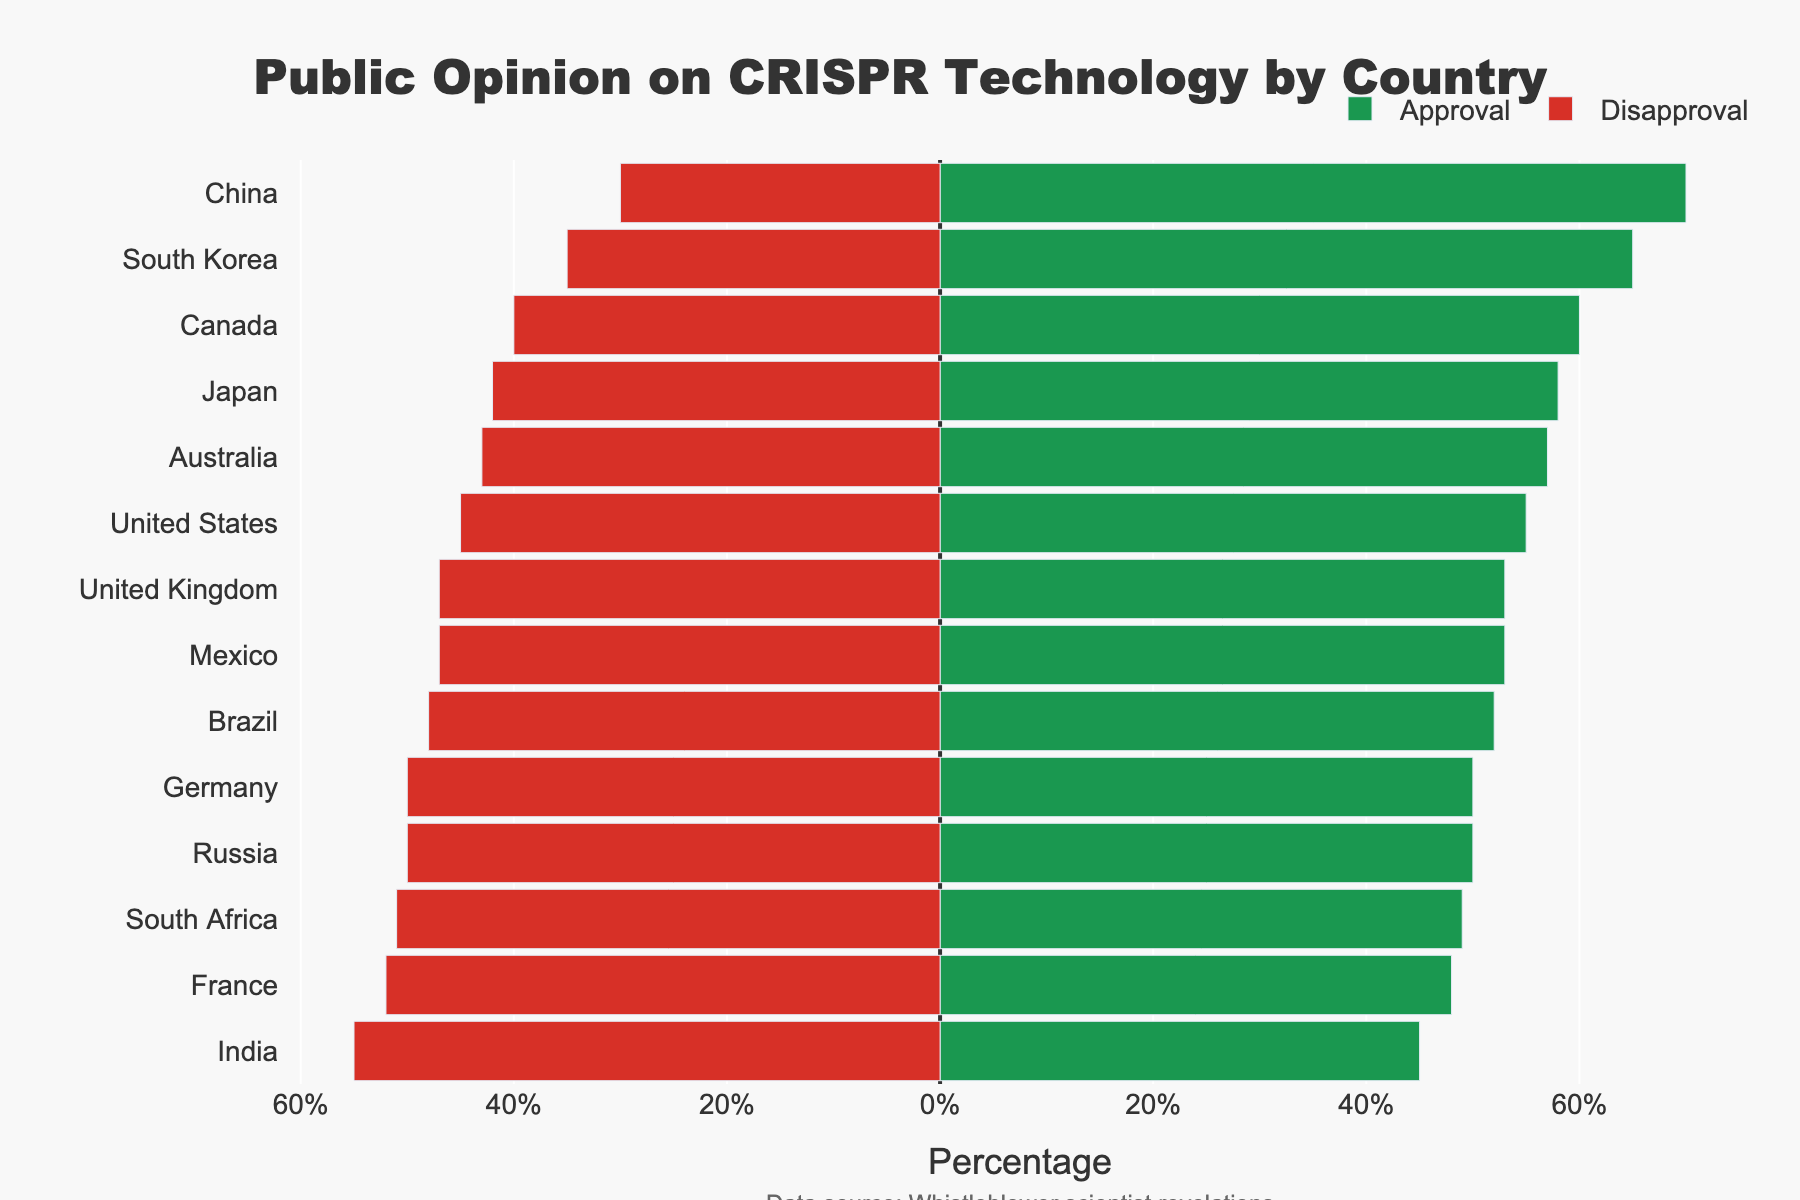Which country has the highest public approval for CRISPR technology? From the chart, look for the country with the longest green bar towards the right. This indicates the highest approval percentage.
Answer: China Which country has more disapproval than approval of CRISPR technology? Identify the country/countries with longer red bars towards the left compared to green bars towards the right. This indicates a higher disapproval percentage than approval.
Answer: France, India, South Africa What is the difference in public approval between South Korea and Japan? Look at the percentage values for South Korea and Japan's public approval, then calculate the difference (65 - 58).
Answer: 7% Among the countries where the public approval and disapproval are equal, name one. Identify the country/countries where the green and red bars are equal in length, indicating equal approval and disapproval percentages.
Answer: Germany, Russia Which country has the smallest gap between public approval and disapproval for CRISPR technology? Find the country with the shortest difference between the green and red bars, indicating the smallest gap.
Answer: Germany, Russia Compare the public approval percentages of the United Kingdom and Brazil. Which one is higher? Look at the percentage values for the United Kingdom and Brazil's public approval, then determine which is higher (53% for UK > 52% for Brazil).
Answer: United Kingdom If you sum up the approval percentages of Canada and Australia, what would be the total? Add the approval percentages of Canada (60) and Australia (57).
Answer: 117% Which countries have an approval rate above 60%? Identify the countries with green bars extending beyond the 60% mark.
Answer: Canada, South Korea, China How much higher is China's public approval compared to the United States? Subtract the approval percentage of the United States from China (70 - 55).
Answer: 15% What is the average public disapproval percentage across all countries shown? Sum the public disapproval percentages for all countries and divide by the number of countries (14): (45+40+50+52+47+42+35+30+55+48+43+50+51+47) / 14 = 549 / 14 ≈ 39.2
Answer: 39.2% 